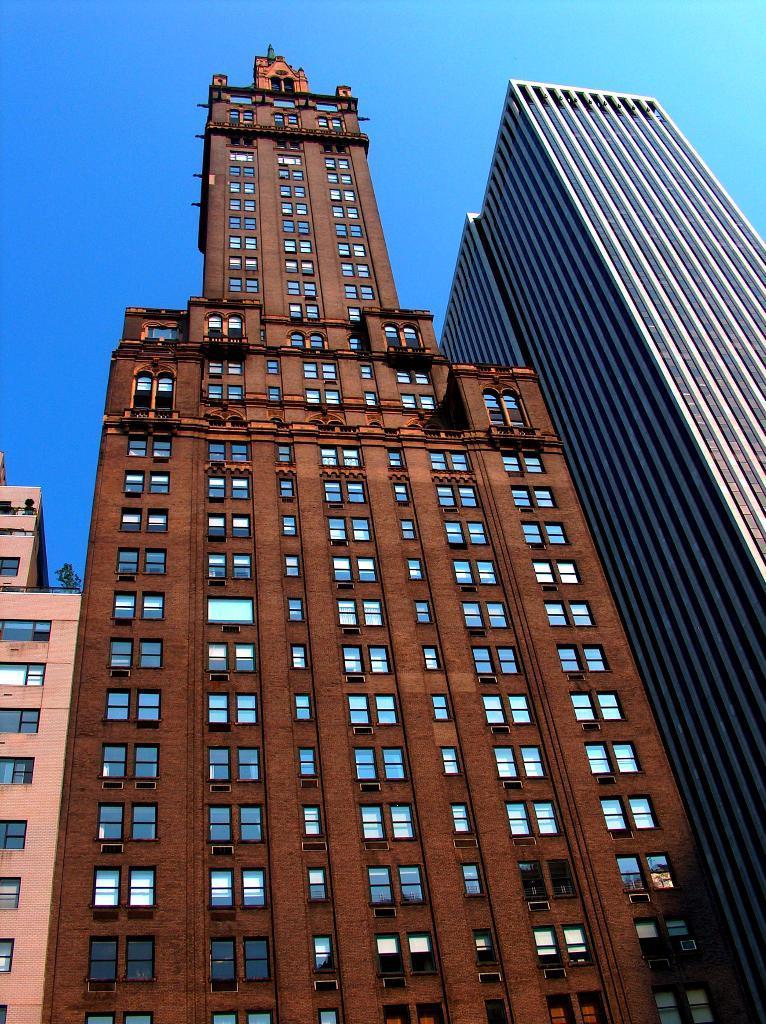Describe this image in one or two sentences. In this picture we can observe buildings. There are windows in this buildings. We can observe blue, brown and pink color buildings. In the background there is a sky. 